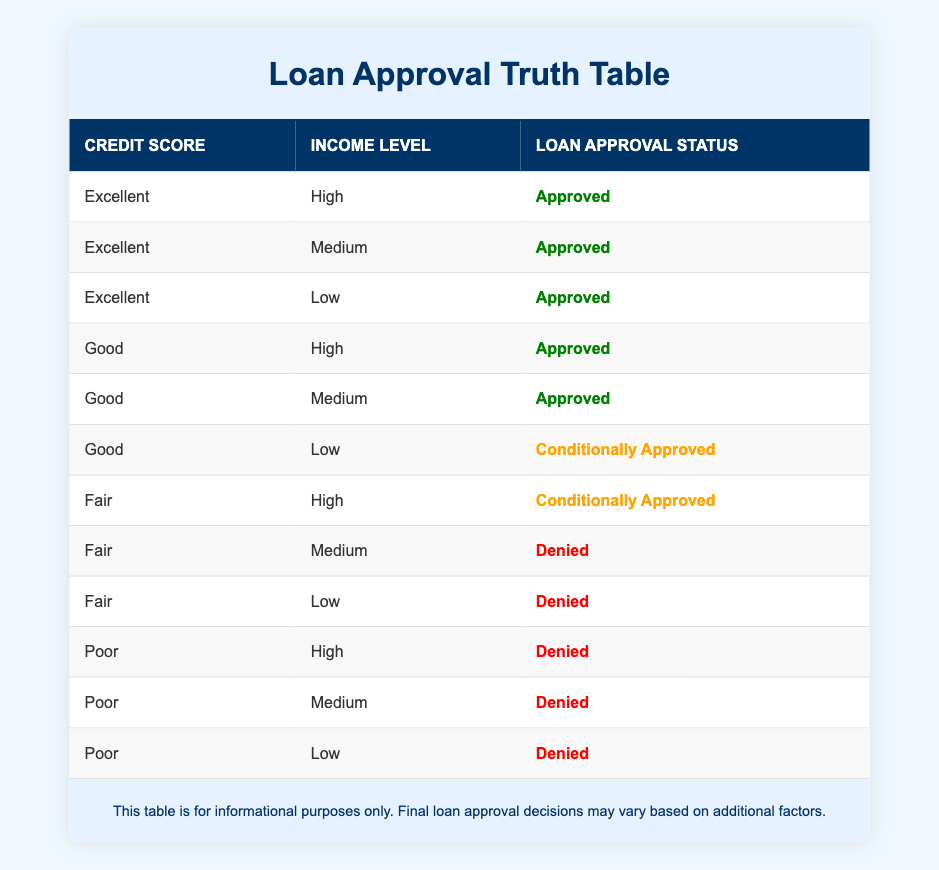What is the loan approval status for applicants with an Excellent credit score and Low income? According to the table, for those with an Excellent credit score and Low income, the Loan Approval Status is "Approved."
Answer: Approved How many different income levels are associated with a "Conditionally Approved" loan status? The table shows "Conditionally Approved" for the following income levels: Low (1), High (1), and Medium (1). Therefore, there are 2 unique income levels.
Answer: 2 Is it true that all applicants with a Poor credit score were denied loans? Reviewing the table indicates that all rows with a Poor credit score show "Denied" as the Loan Approval Status. Thus, it is true.
Answer: Yes What is the total number of applicants who received an "Approved" loan status? The table lists multiple instances of "Approved." Specifically, there are 7 applicants who received this status (3 Excellent + 2 Good + 2 Good).
Answer: 7 Which credit score levels are associated with a loan status of "Denied"? Analyzing the table reveals that the credit score levels of "Fair" and "Poor" are associated with a loan status of "Denied."
Answer: Fair, Poor What percentage of applicants with a Good credit score received "Approved" versus "Conditionally Approved" statuses? For applicants with a Good credit score: 2 were "Approved" and 1 was "Conditionally Approved." Thus, the percentages are 67% Approved and 33% Conditionally Approved.
Answer: 67% Approved, 33% Conditionally Approved How many total applicants are classified in the table as having a Fair credit score with a high income? The table clearly indicates that there is only 1 applicant with a Fair credit score and High income, which corresponds to the status "Conditionally Approved."
Answer: 1 If an applicant has a Good credit score and a Low income, what should they expect regarding their loan approval? The data shows that an applicant with a Good credit score and Low income would receive a "Conditionally Approved" status.
Answer: Conditionally Approved What is the difference in approval statuses between applicants with Excellent credit scores and those with Poor credit scores? For Excellent credit scores, all statuses are "Approved," while for Poor credit scores, all statuses are "Denied." The difference is significant, as Excellent scores yield approvals, while Poor scores result in denial.
Answer: Excellent: Approved; Poor: Denied 